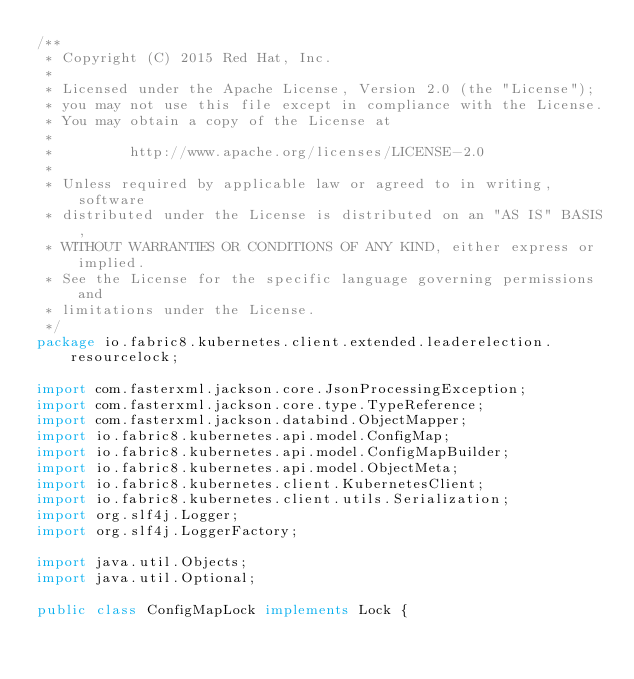<code> <loc_0><loc_0><loc_500><loc_500><_Java_>/**
 * Copyright (C) 2015 Red Hat, Inc.
 *
 * Licensed under the Apache License, Version 2.0 (the "License");
 * you may not use this file except in compliance with the License.
 * You may obtain a copy of the License at
 *
 *         http://www.apache.org/licenses/LICENSE-2.0
 *
 * Unless required by applicable law or agreed to in writing, software
 * distributed under the License is distributed on an "AS IS" BASIS,
 * WITHOUT WARRANTIES OR CONDITIONS OF ANY KIND, either express or implied.
 * See the License for the specific language governing permissions and
 * limitations under the License.
 */
package io.fabric8.kubernetes.client.extended.leaderelection.resourcelock;

import com.fasterxml.jackson.core.JsonProcessingException;
import com.fasterxml.jackson.core.type.TypeReference;
import com.fasterxml.jackson.databind.ObjectMapper;
import io.fabric8.kubernetes.api.model.ConfigMap;
import io.fabric8.kubernetes.api.model.ConfigMapBuilder;
import io.fabric8.kubernetes.api.model.ObjectMeta;
import io.fabric8.kubernetes.client.KubernetesClient;
import io.fabric8.kubernetes.client.utils.Serialization;
import org.slf4j.Logger;
import org.slf4j.LoggerFactory;

import java.util.Objects;
import java.util.Optional;

public class ConfigMapLock implements Lock {
</code> 